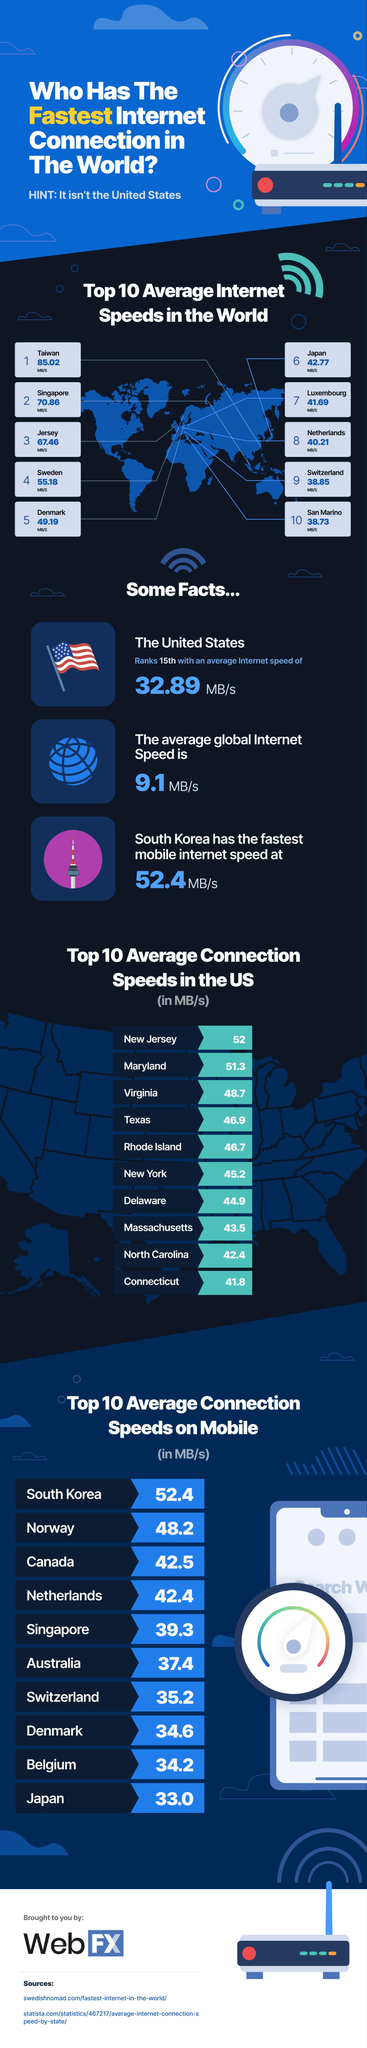Give some essential details in this illustration. According to data, the state of New Jersey has the highest average connection speed among all US states. South Korea has the highest average connection speeds on mobile devices, making it the country with the best mobile internet access. Taiwan has the highest average internet speeds in the world. 